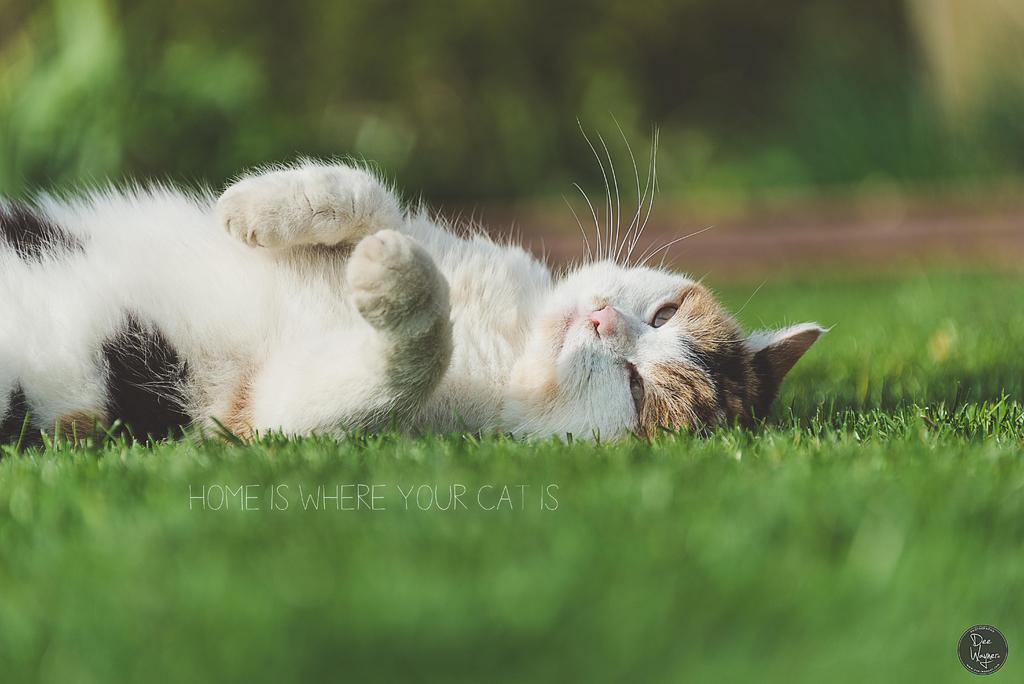Could you give a brief overview of what you see in this image? In this picture I can see a cat and grass on the ground and I can see text in the middle of the picture and I can see a logo at the bottom right corner of the picture and I can see blurry background. 